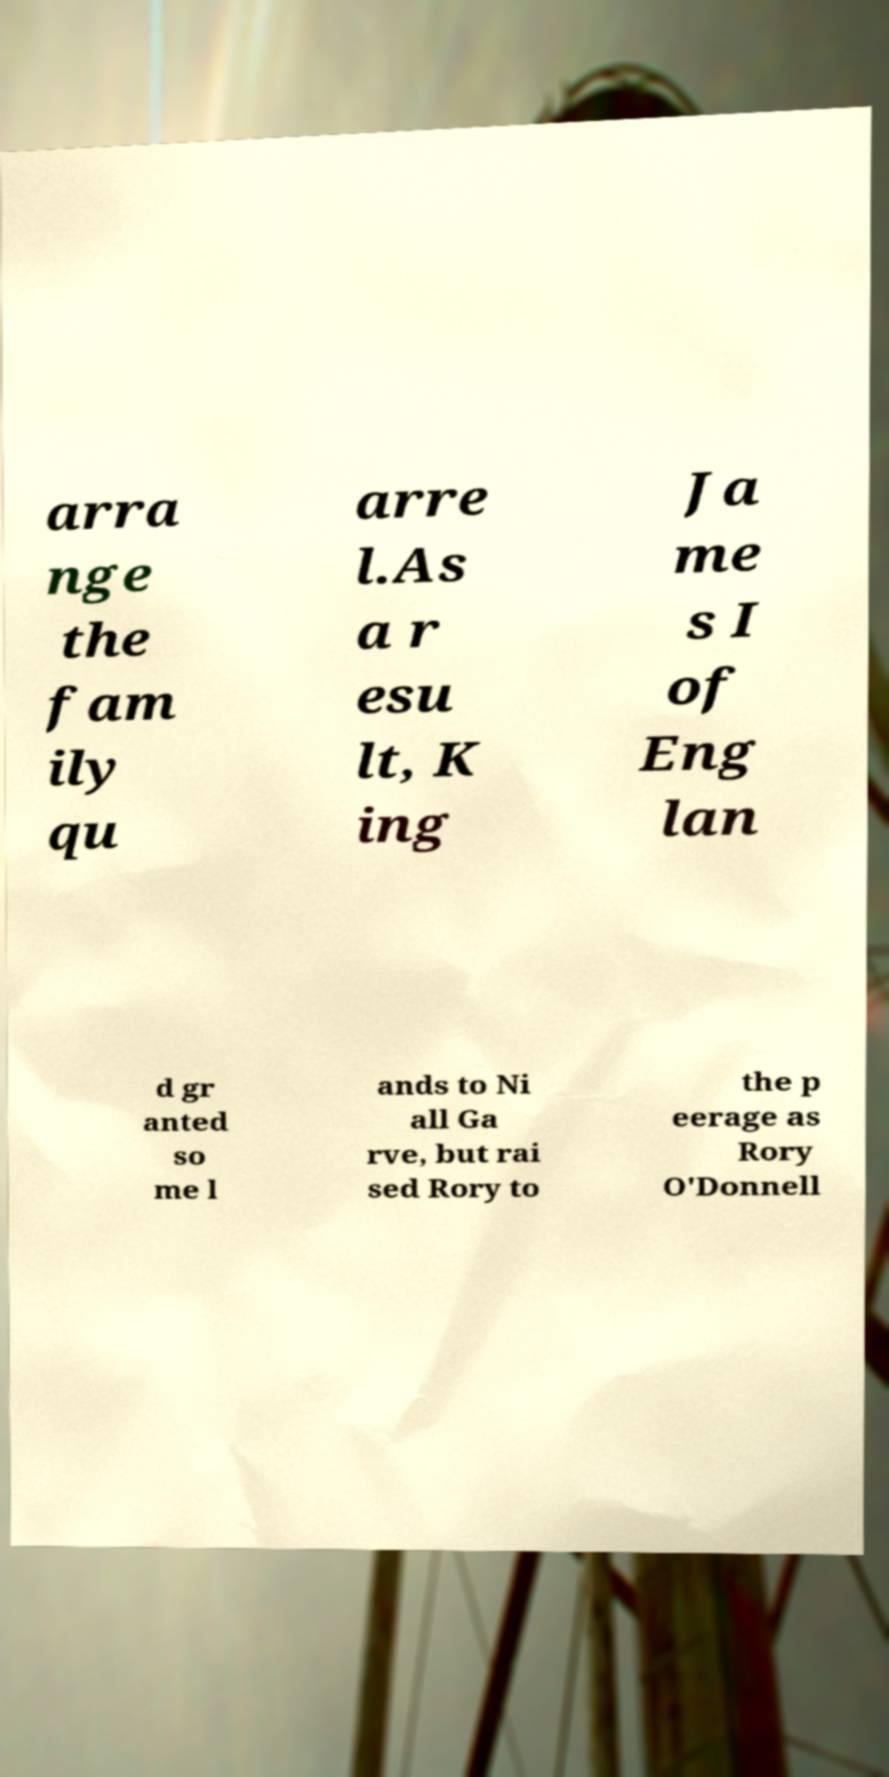There's text embedded in this image that I need extracted. Can you transcribe it verbatim? arra nge the fam ily qu arre l.As a r esu lt, K ing Ja me s I of Eng lan d gr anted so me l ands to Ni all Ga rve, but rai sed Rory to the p eerage as Rory O'Donnell 